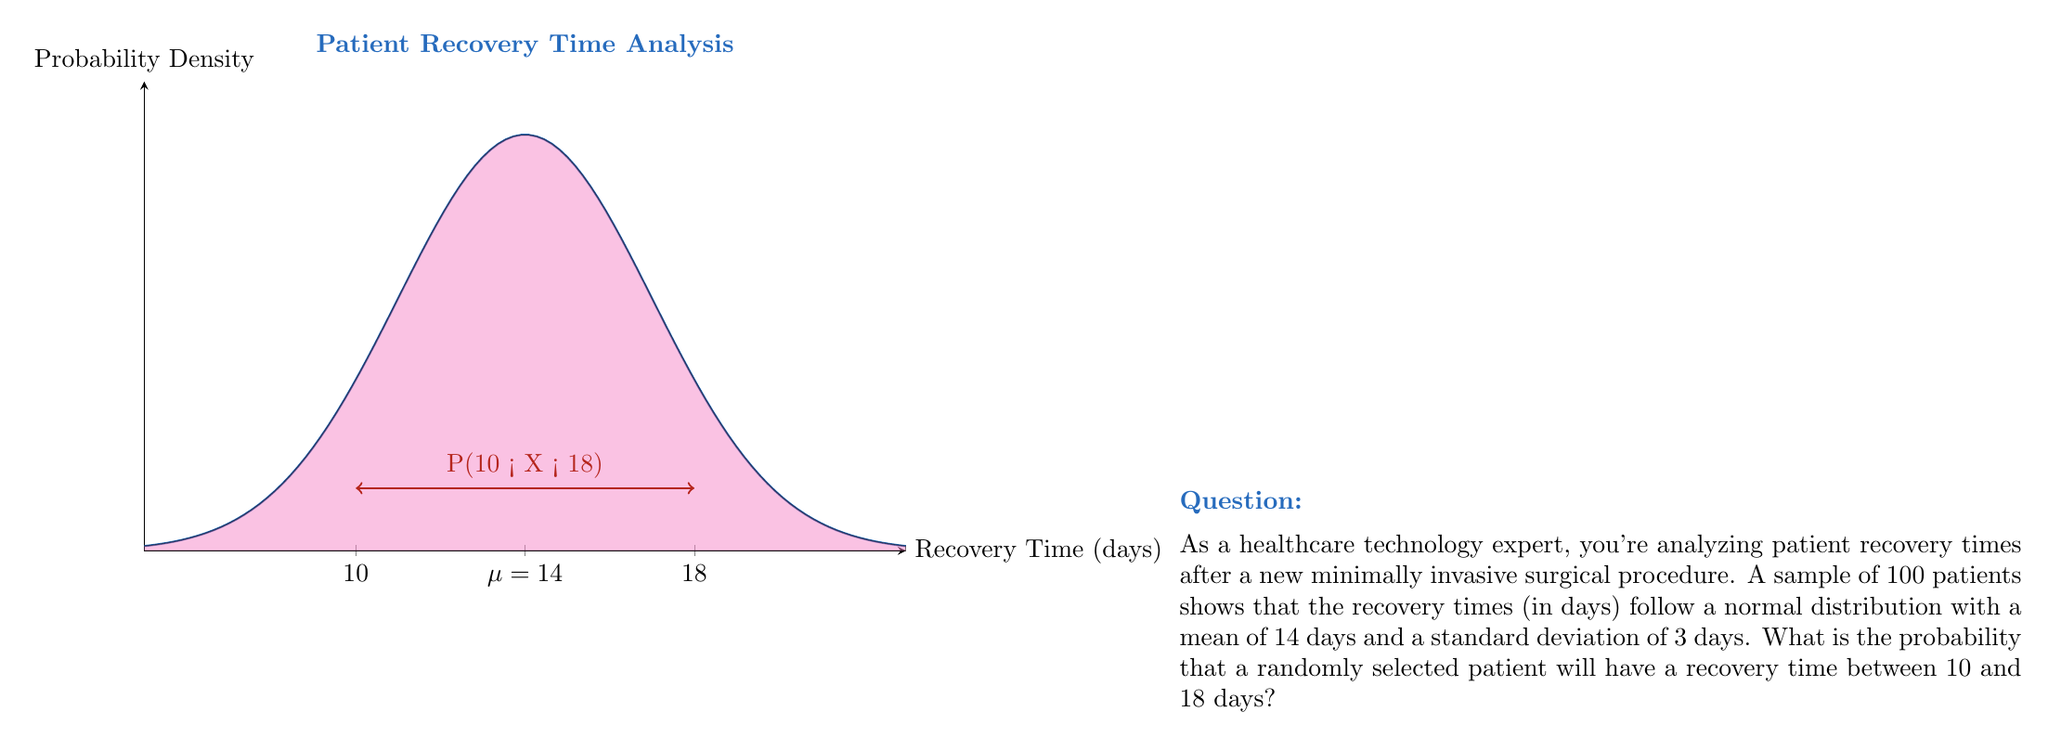Teach me how to tackle this problem. To solve this problem, we'll use the properties of the normal distribution and the concept of z-scores.

Step 1: Identify the given information
- Mean ($\mu$) = 14 days
- Standard deviation ($\sigma$) = 3 days
- We want the probability of recovery time between 10 and 18 days

Step 2: Convert the given values to z-scores
For the lower bound: $z_1 = \frac{10 - 14}{3} = -1.33$
For the upper bound: $z_2 = \frac{18 - 14}{3} = 1.33$

Step 3: Use the standard normal distribution table or a calculator to find the area under the curve between these z-scores

The probability is equal to the area between $z_1$ and $z_2$.

$P(-1.33 < Z < 1.33) = P(Z < 1.33) - P(Z < -1.33)$

Using a standard normal table or calculator:
$P(Z < 1.33) \approx 0.9082$
$P(Z < -1.33) \approx 0.0918$

Therefore, $P(-1.33 < Z < 1.33) = 0.9082 - 0.0918 = 0.8164$

Step 4: Convert the result to a percentage
0.8164 * 100% = 81.64%
Answer: 81.64% 